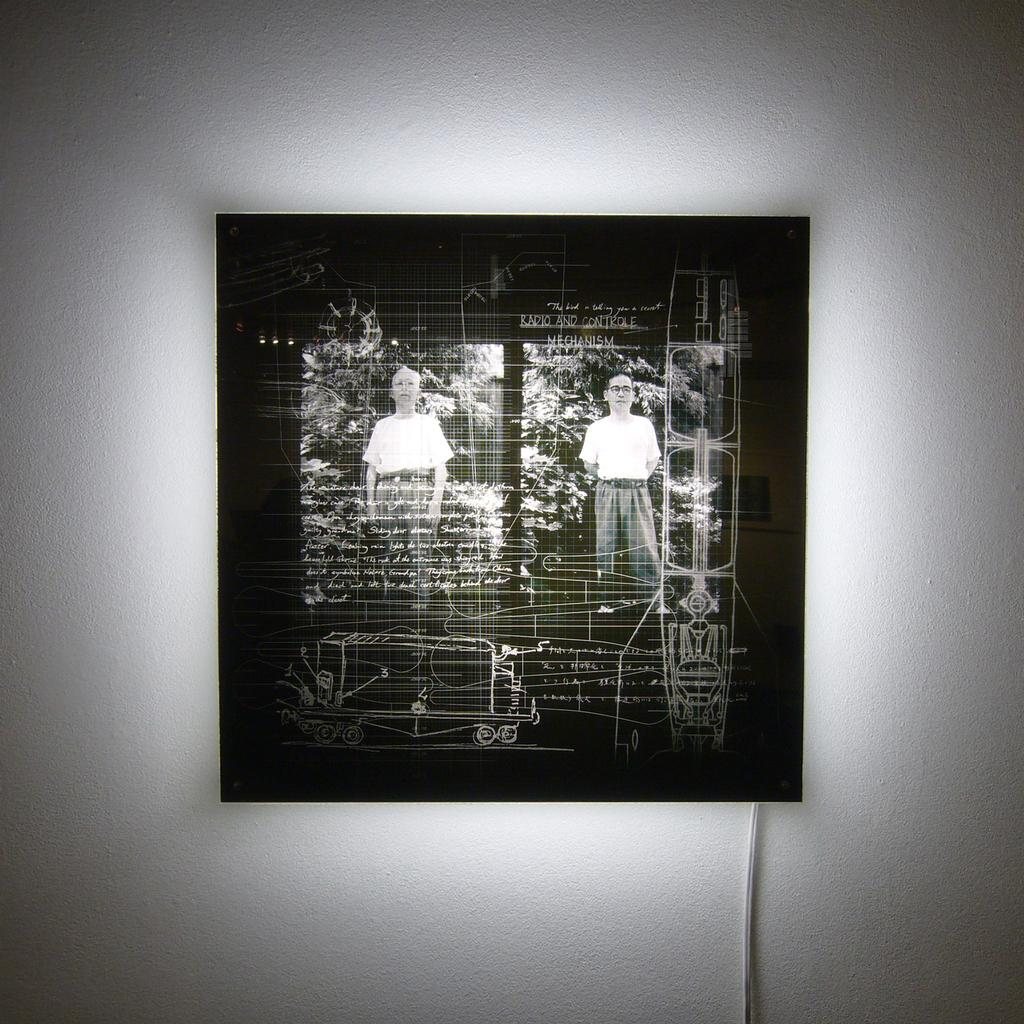What is on the wall in the image? There is a frame on the wall in the image. What is happening with the frame in the image? There are persons standing on the frame. What type of natural scenery can be seen in the image? Trees are visible in the image. What position do the persons need to be in to pull the frame off the wall? There is no indication in the image that the persons are trying to pull the frame off the wall, so it's not possible to determine what position they would need to be in. 